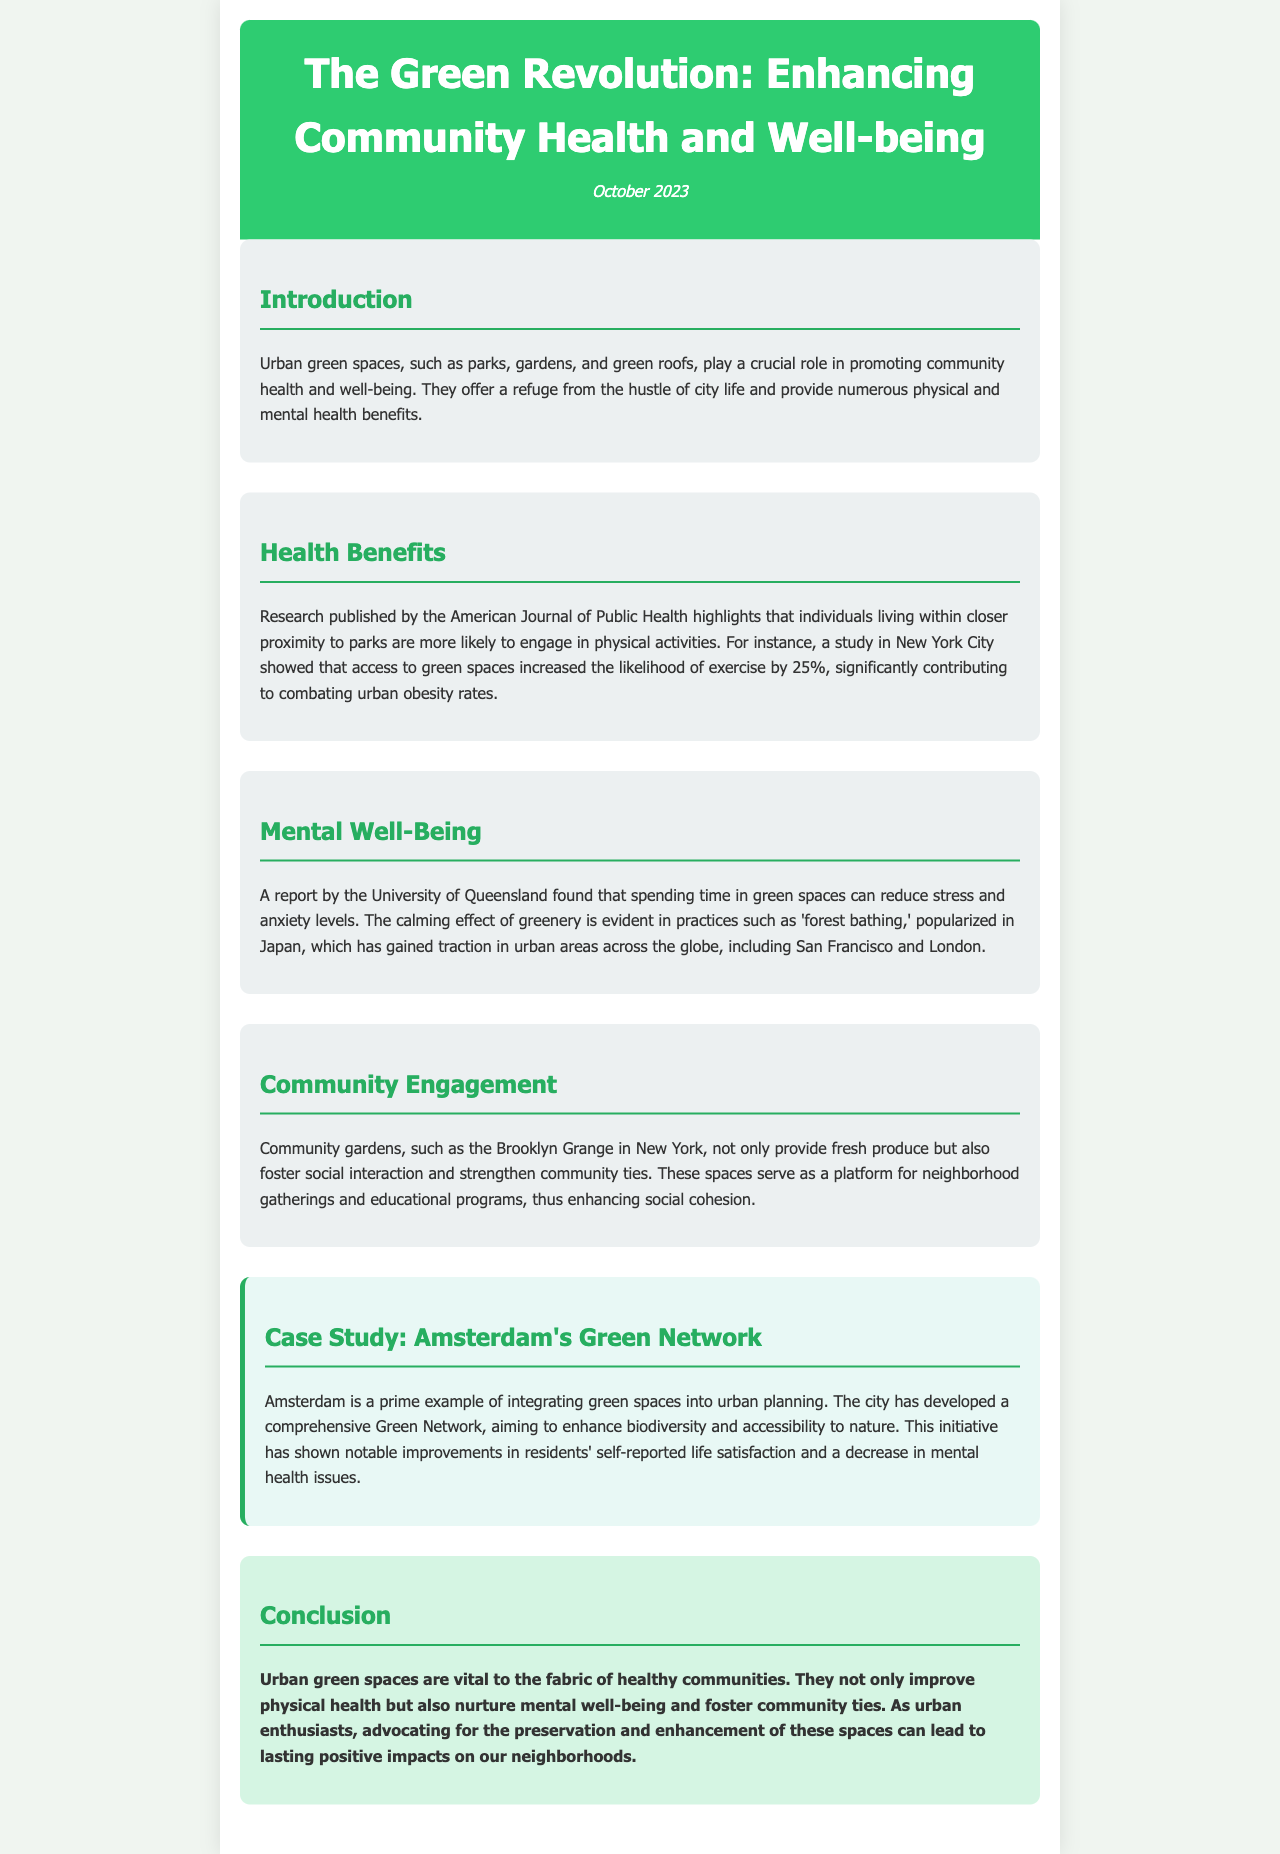What is the title of the newsletter? The title of the newsletter is prominently displayed in the header section of the document.
Answer: The Green Revolution: Enhancing Community Health and Well-being What month and year was the newsletter published? The publication date is mentioned in the header section along with the title.
Answer: October 2023 What benefit is associated with access to green spaces according to the American Journal of Public Health? This benefit is highlighted in the Health Benefits section, specifically focused on physical activity.
Answer: Increased likelihood of exercise Which city is mentioned as having community gardens like the Brooklyn Grange? The city is referenced in the Community Engagement section discussing the impact of community gardens.
Answer: New York What practice, popularized in Japan, is mentioned to reduce stress and anxiety? The practice is referenced in the Mental Well-Being section as a beneficial activity associated with green spaces.
Answer: Forest bathing How much did the likelihood of exercise increase by for individuals close to green spaces? This statistic is found in the Health Benefits section and quantifies the increase in physical activity due to access to parks.
Answer: 25% What is a primary example of a city that has integrated green spaces into urban planning? This example is given in the Case Study section showcasing efforts towards urban sustainability.
Answer: Amsterdam What is the main conclusion about urban green spaces? The final thoughts are summarized in the Conclusion section regarding their overall importance.
Answer: Vital to the fabric of healthy communities 